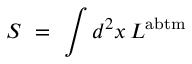<formula> <loc_0><loc_0><loc_500><loc_500>S = \int d ^ { 2 } x \, L ^ { a b t m }</formula> 